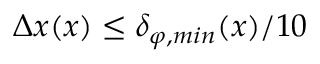Convert formula to latex. <formula><loc_0><loc_0><loc_500><loc_500>\Delta x ( x ) \leq \delta _ { \varphi , \min } ( x ) / 1 0</formula> 